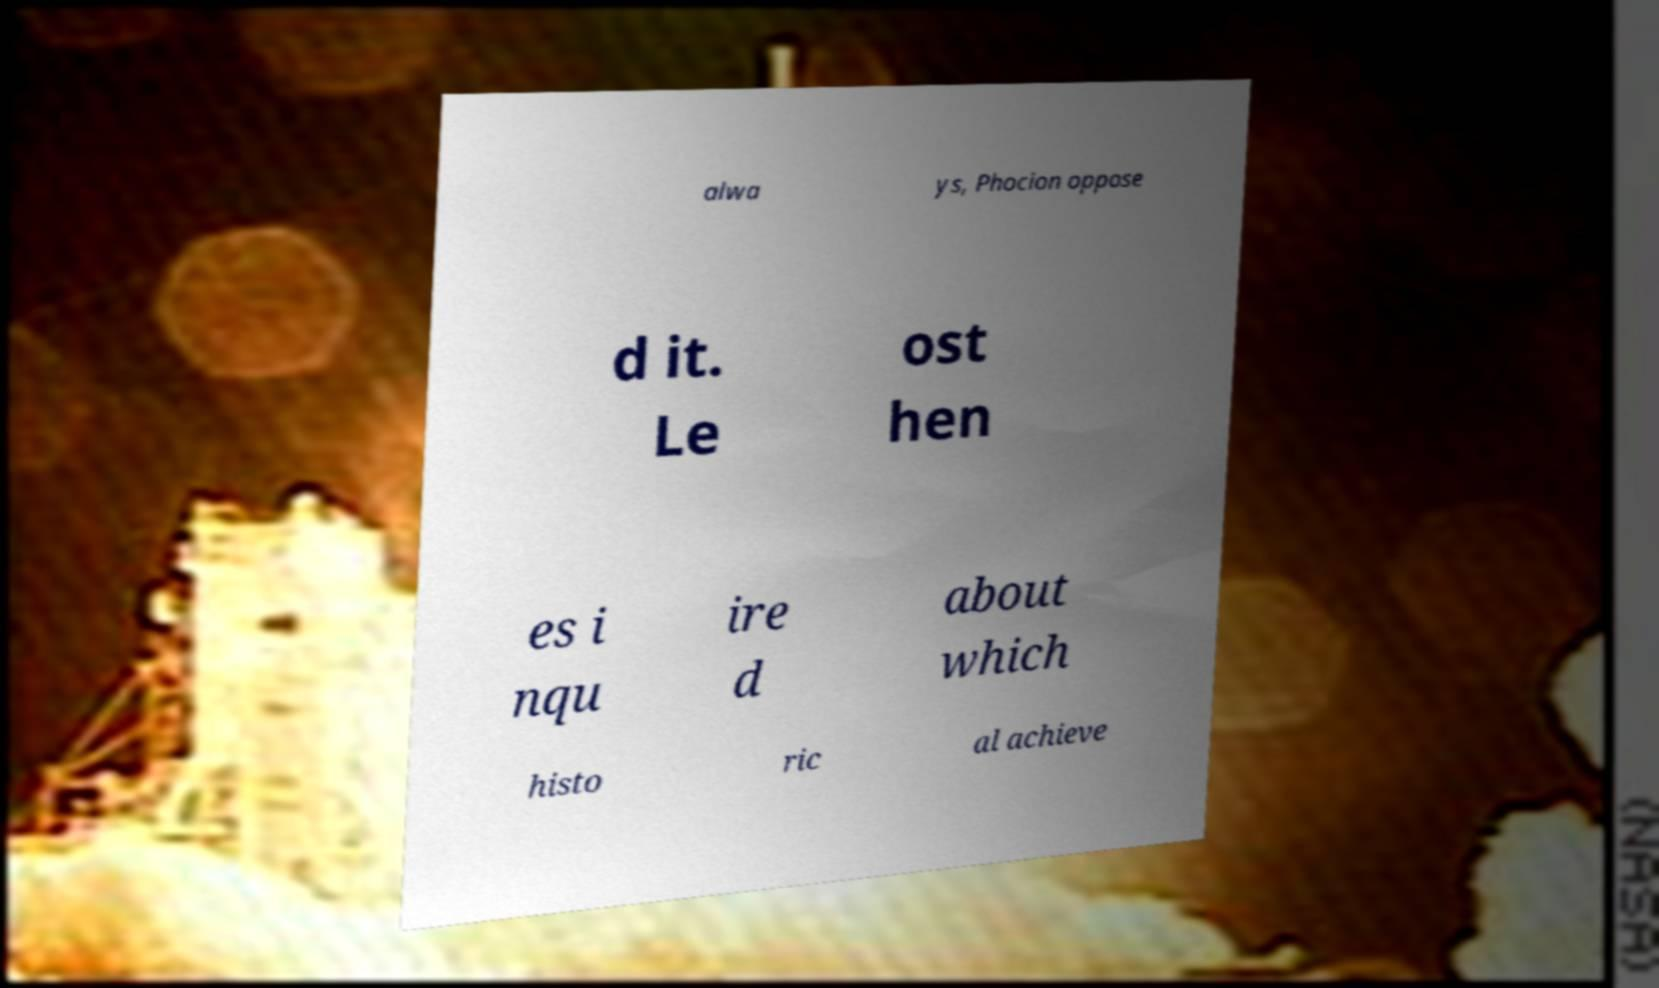Please read and relay the text visible in this image. What does it say? alwa ys, Phocion oppose d it. Le ost hen es i nqu ire d about which histo ric al achieve 